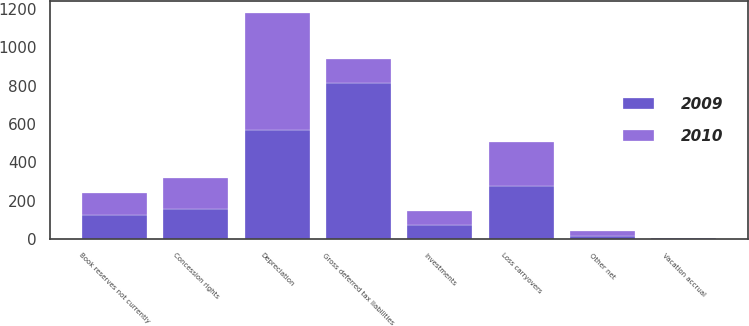<chart> <loc_0><loc_0><loc_500><loc_500><stacked_bar_chart><ecel><fcel>Depreciation<fcel>Investments<fcel>Concession rights<fcel>Other net<fcel>Gross deferred tax liabilities<fcel>Loss carryovers<fcel>Book reserves not currently<fcel>Vacation accrual<nl><fcel>2010<fcel>609.9<fcel>74.1<fcel>163.1<fcel>22.7<fcel>124.6<fcel>227.6<fcel>113.4<fcel>3.7<nl><fcel>2009<fcel>571.2<fcel>74<fcel>154.6<fcel>16.7<fcel>816.5<fcel>276.5<fcel>124.6<fcel>3.6<nl></chart> 